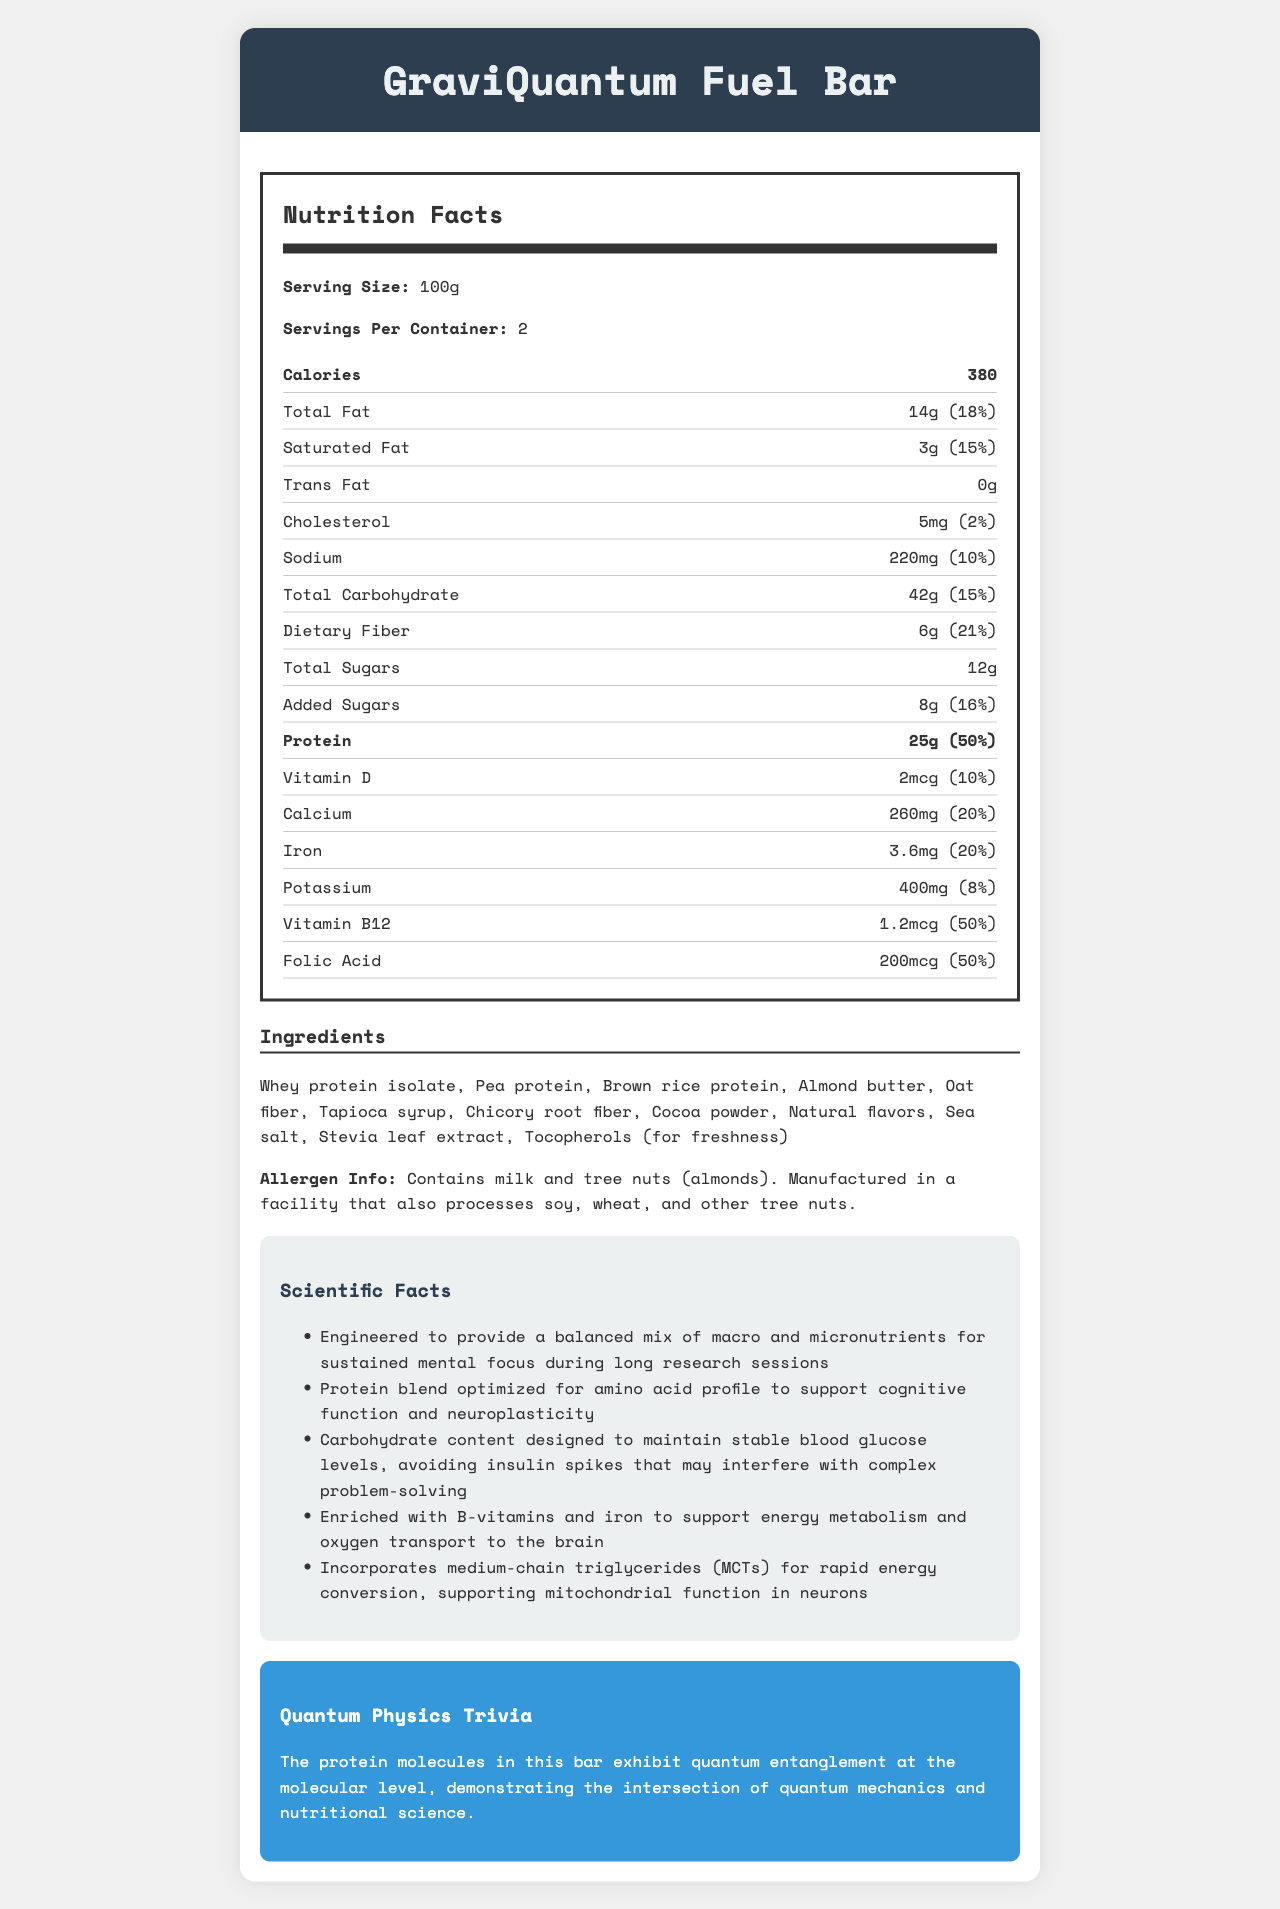what is the serving size of the GraviQuantum Fuel Bar? The serving size is explicitly mentioned in the "Nutrition Facts" section as "Serving Size: 100g."
Answer: 100g how many grams of total protein are there in the entire container? There are 25g of protein per serving and 2 servings per container, so 25g * 2 = 50g of total protein in the entire container.
Answer: 50g how much dietary fiber is in one serving, and what percentage of the daily value does it provide? The document lists dietary fiber as 6g per serving, which is 21% of the daily value.
Answer: 6g, 21% what is the total calorie content if you consume the entire container? One serving contains 380 calories, and there are two servings per container: 380 calories * 2 = 760 calories.
Answer: 760 calories what are the main types of protein sources in the GraviQuantum Fuel Bar? These are listed as the first three ingredients under the "Ingredients" section.
Answer: Whey protein isolate, Pea protein, Brown rice protein which of the following vitamins have the highest daily value percentage in one serving? A. Vitamin D B. Calcium C. Iron D. Vitamin B12 Vitamin D has 10%, Calcium has 20%, Iron has 20%, but Vitamin B12 has 50%, the highest daily value percentage.
Answer: D what is one of the scientific reasons for the inclusion of B-vitamins and iron in the bar? A. To improve sleep cycles B. To support energy metabolism and oxygen transport to the brain C. To enhance muscle growth D. To support cardiovascular health The "Scientific Facts" section states that B-vitamins and iron support energy metabolism and oxygen transport to the brain.
Answer: B is the GraviQuantum Fuel Bar suitable for someone with a nut allergy? The "Allergen Info" section clearly states that the bar contains milk and tree nuts (almonds) and is manufactured in a facility that processes other tree nuts.
Answer: No what is the primary type of sugar added to the GraviQuantum Fuel Bar, and how much is present per serving? The "Nutrition Facts" section lists "Added Sugars" as 8g per serving.
Answer: Added Sugars, 8g do the protein molecules in this bar exhibit quantum entanglement? The "Quantum Physics Trivia" section states that the protein molecules in this bar exhibit quantum entanglement at the molecular level.
Answer: Yes summarize the main idea of the GraviQuantum Fuel Bar document. The document focuses on presenting all the nutritional details, ingredients, allergen information, scientific advantages, and an interesting quantum physics trivia about the bar.
Answer: The document provides a comprehensive breakdown of the nutritional content, ingredients, and benefits of the GraviQuantum Fuel Bar. It emphasizes its high-protein content, designed to support mental focus and cognitive function with a mix of macro and micronutrients, and ends with a unique trivia about quantum entanglement. how many grams of trans fat does the GraviQuantum Fuel Bar contain per serving? The "Nutrition Facts" section lists Trans Fat as 0g.
Answer: 0g what role do medium-chain triglycerides (MCTs) play in the GraviQuantum Fuel Bar? As explained in the "Scientific Facts" section, MCTs are included to aid rapid energy conversion, supporting mitochondrial function in neurons.
Answer: Supporting mitochondrial function in neurons which of these ingredients is listed last in the ingredient list? A. Sea salt B. Stevia leaf extract C. Tocopherols D. Natural flavors Tocopherols (for freshness) are listed last in the ingredient list.
Answer: C what percentage of the daily value of folic acid does one serving provide? According to the "Nutrition Facts" section, one serving provides 50% of the daily value for folic acid.
Answer: 50% what is the main source of sweetness in the GraviQuantum Fuel Bar? These ingredients are listed in the "Ingredients" section and are typically used as sweeteners.
Answer: Tapioca syrup, Stevia leaf extract does the GraviQuantum Fuel Bar help maintain stable blood glucose levels? The "Scientific Facts" section mentions that the carbohydrate content is designed to maintain stable blood glucose levels.
Answer: True is the manufacturer of the GraviQuantum Fuel Bar disclosed in the document? The document does not provide any details about the manufacturer, only that it is manufactured in a facility processing certain allergens.
Answer: Not enough information 